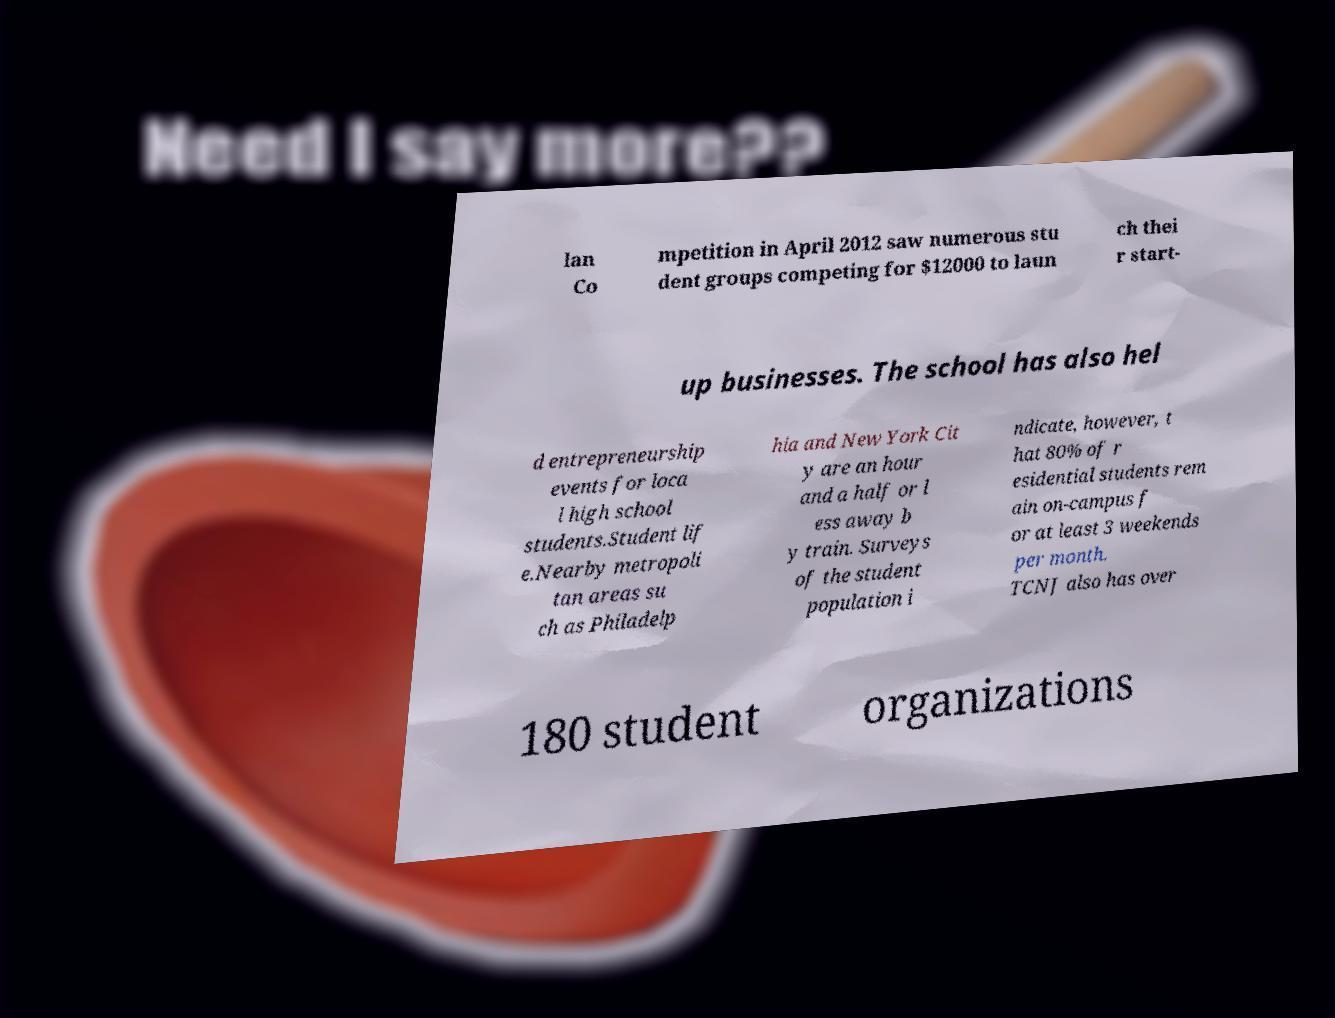There's text embedded in this image that I need extracted. Can you transcribe it verbatim? lan Co mpetition in April 2012 saw numerous stu dent groups competing for $12000 to laun ch thei r start- up businesses. The school has also hel d entrepreneurship events for loca l high school students.Student lif e.Nearby metropoli tan areas su ch as Philadelp hia and New York Cit y are an hour and a half or l ess away b y train. Surveys of the student population i ndicate, however, t hat 80% of r esidential students rem ain on-campus f or at least 3 weekends per month. TCNJ also has over 180 student organizations 